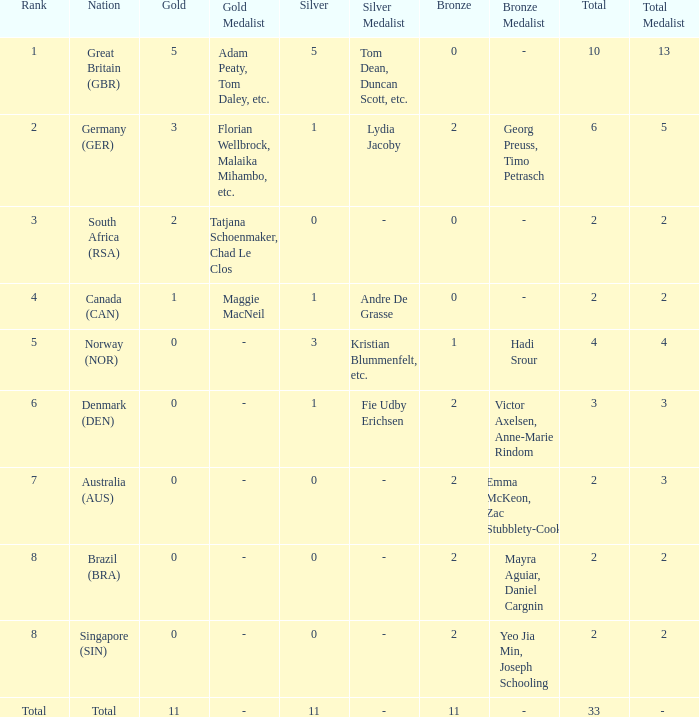What is bronze when the rank is 3 and the total is more than 2? None. 